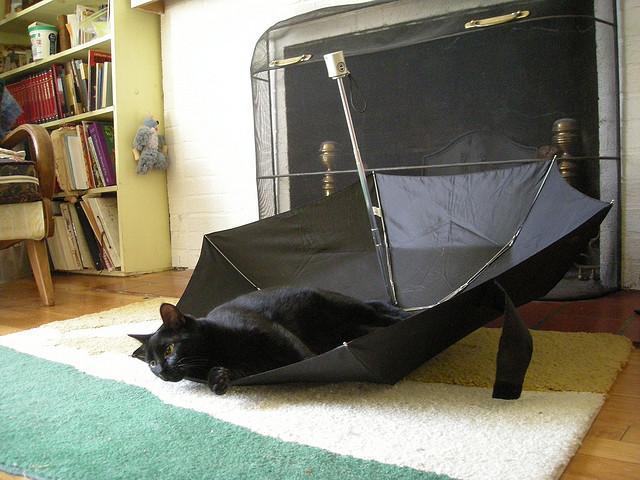How many cats are there?
Give a very brief answer. 1. 